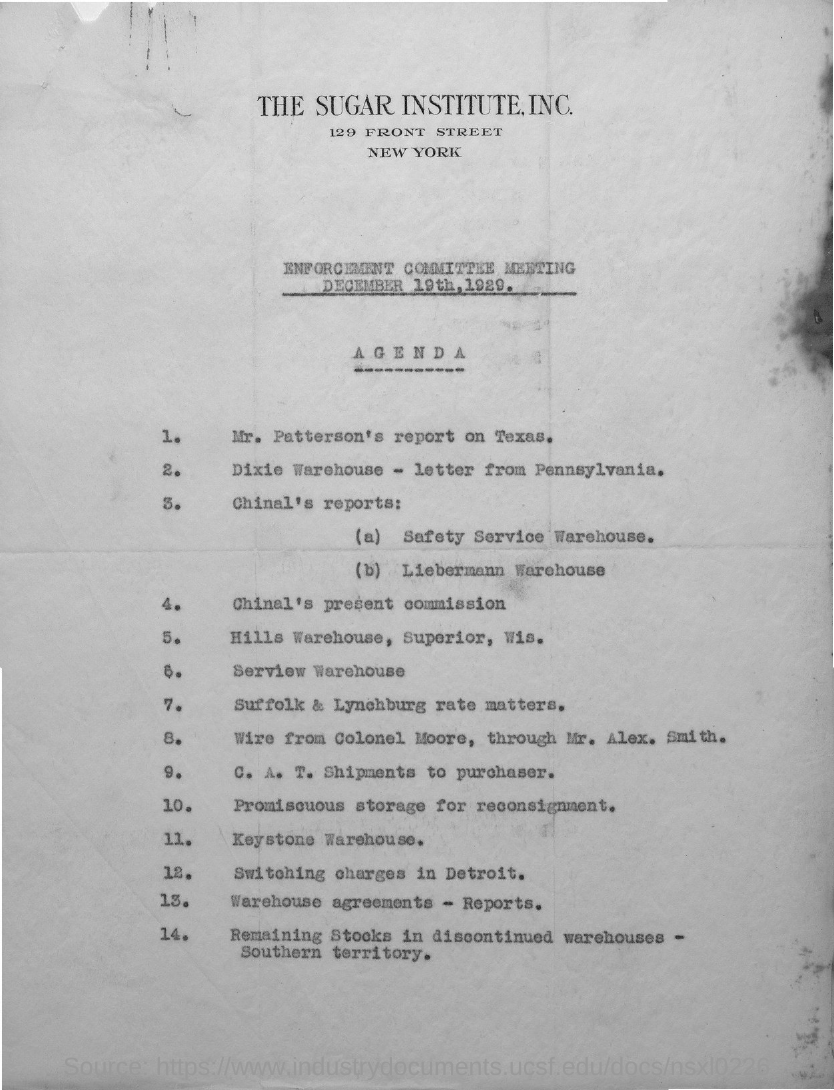Which organization's  name is in the letter head?
Provide a succinct answer. The sugar institute,inc. 